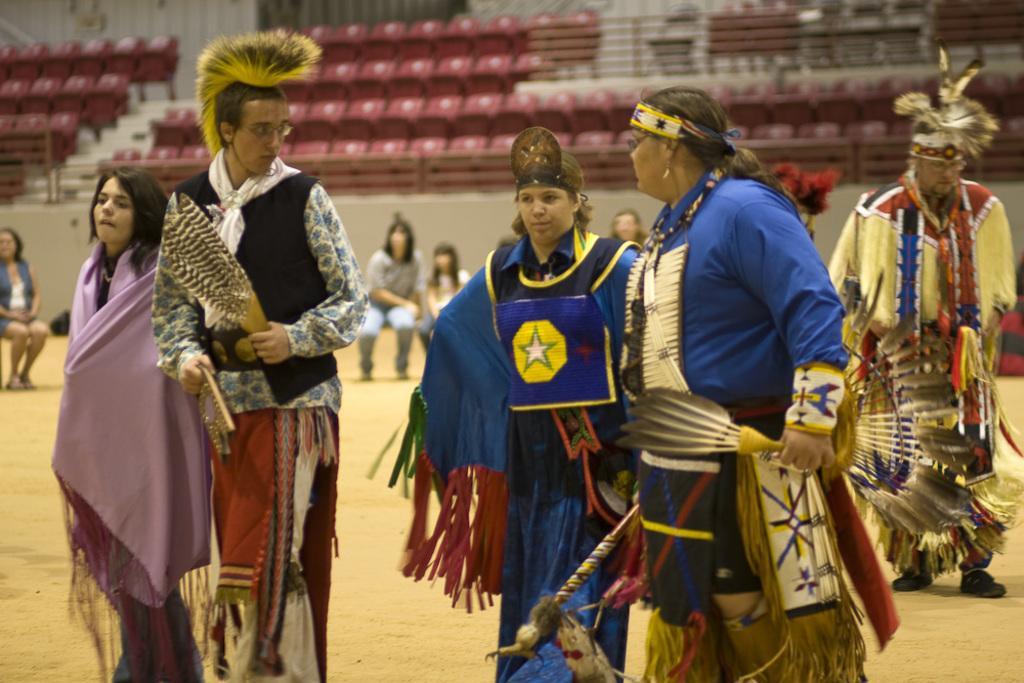How many men and women are present in the image? There are two men and three women in the image. Where are the people standing in the image? The people are standing on the land. What are the people wearing in the image? The people are wearing different costumes. Can you describe the background of the image? In the background of the image, there are people and chairs. How many boys are holding bananas in the image? There are no boys or bananas present in the image. Is there a servant attending to the people in the image? There is no servant present in the image. 